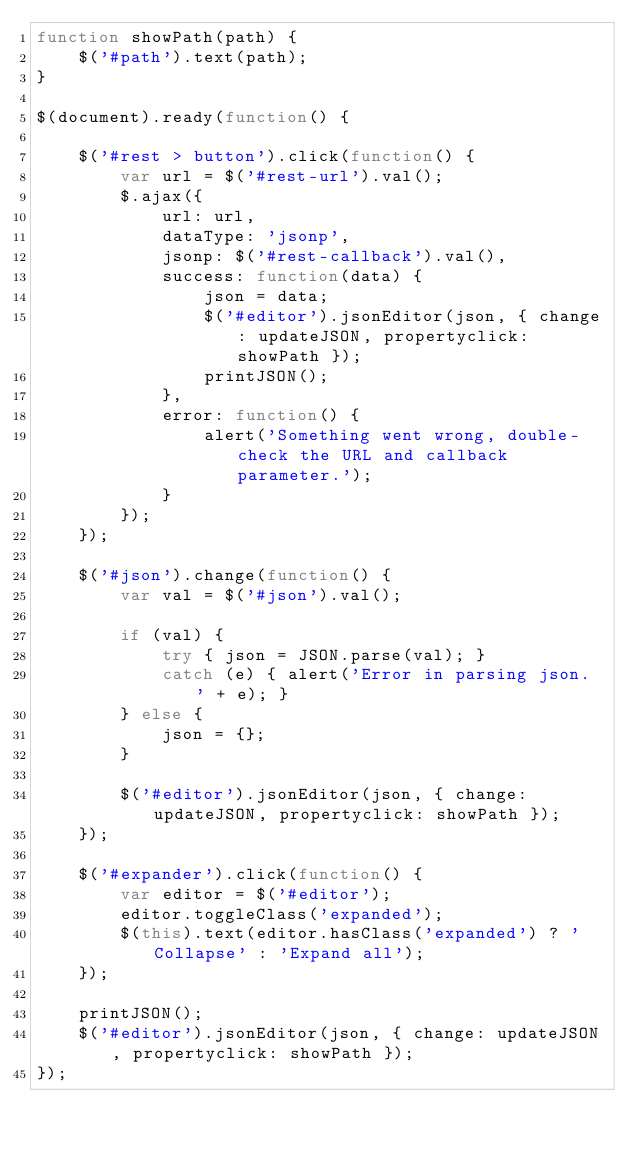<code> <loc_0><loc_0><loc_500><loc_500><_JavaScript_>function showPath(path) {
    $('#path').text(path);
}

$(document).ready(function() {

    $('#rest > button').click(function() {
        var url = $('#rest-url').val();
        $.ajax({
            url: url,
            dataType: 'jsonp',
            jsonp: $('#rest-callback').val(),
            success: function(data) {
                json = data;
                $('#editor').jsonEditor(json, { change: updateJSON, propertyclick: showPath });
                printJSON();
            },
            error: function() {
                alert('Something went wrong, double-check the URL and callback parameter.');
            }
        });
    });

    $('#json').change(function() {
        var val = $('#json').val();

        if (val) {
            try { json = JSON.parse(val); }
            catch (e) { alert('Error in parsing json. ' + e); }
        } else {
            json = {};
        }
        
        $('#editor').jsonEditor(json, { change: updateJSON, propertyclick: showPath });
    });

    $('#expander').click(function() {
        var editor = $('#editor');
        editor.toggleClass('expanded');
        $(this).text(editor.hasClass('expanded') ? 'Collapse' : 'Expand all');
    });
    
    printJSON();
    $('#editor').jsonEditor(json, { change: updateJSON, propertyclick: showPath });
});


</code> 